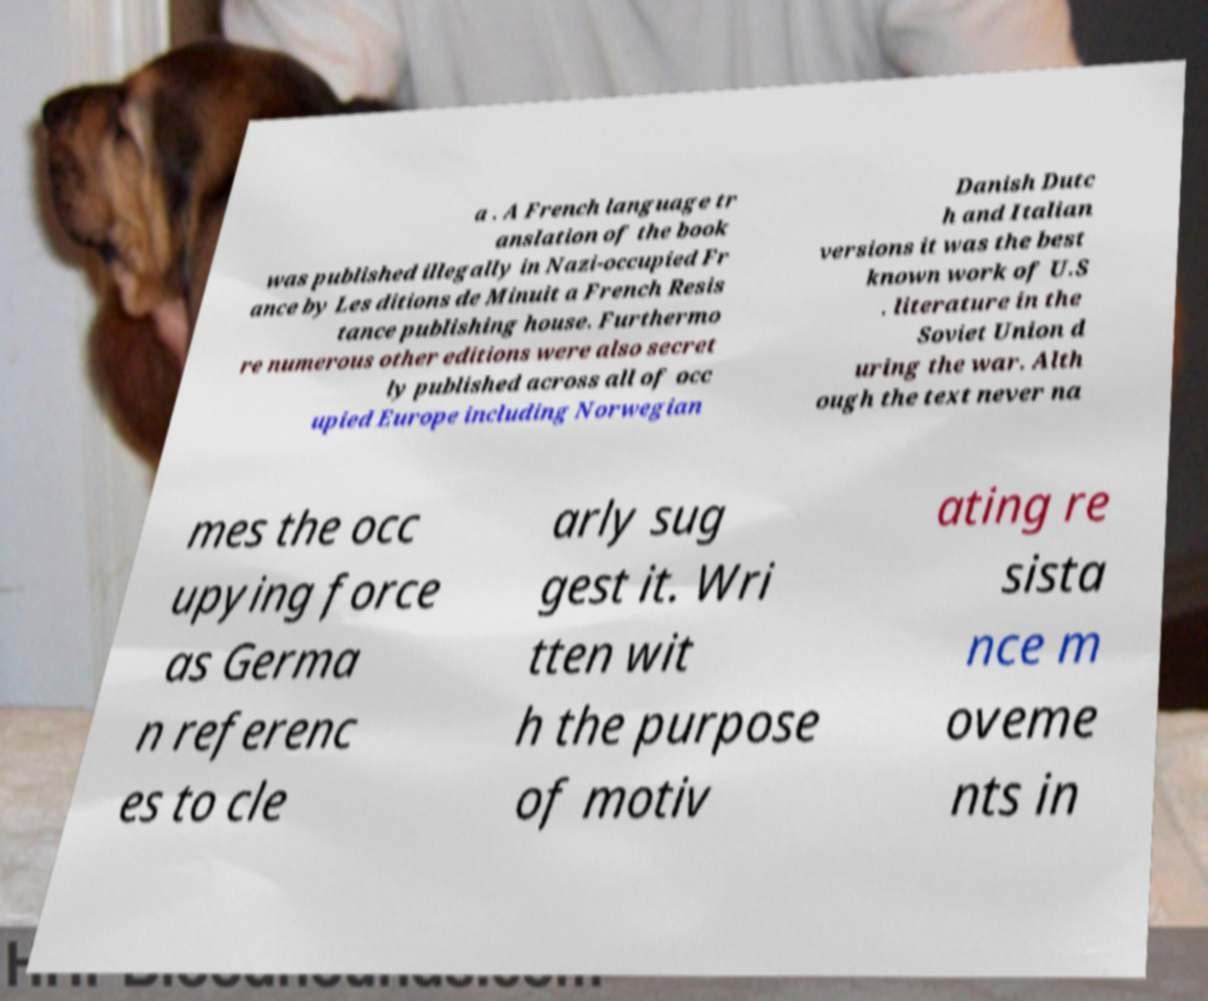Can you accurately transcribe the text from the provided image for me? a . A French language tr anslation of the book was published illegally in Nazi-occupied Fr ance by Les ditions de Minuit a French Resis tance publishing house. Furthermo re numerous other editions were also secret ly published across all of occ upied Europe including Norwegian Danish Dutc h and Italian versions it was the best known work of U.S . literature in the Soviet Union d uring the war. Alth ough the text never na mes the occ upying force as Germa n referenc es to cle arly sug gest it. Wri tten wit h the purpose of motiv ating re sista nce m oveme nts in 